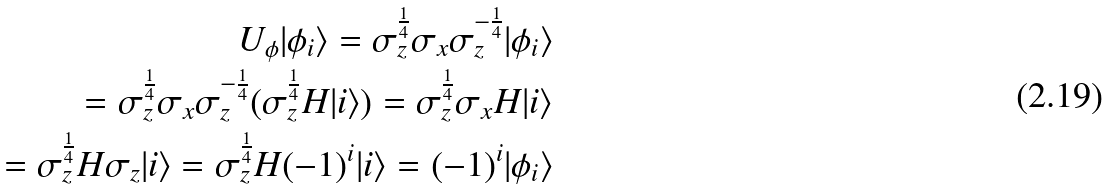<formula> <loc_0><loc_0><loc_500><loc_500>U _ { \phi } | \phi _ { i } \rangle = \sigma _ { z } ^ { \frac { 1 } { 4 } } \sigma _ { x } \sigma _ { z } ^ { - \frac { 1 } { 4 } } | \phi _ { i } \rangle \\ = \sigma _ { z } ^ { \frac { 1 } { 4 } } \sigma _ { x } \sigma _ { z } ^ { - \frac { 1 } { 4 } } ( \sigma _ { z } ^ { \frac { 1 } { 4 } } H | i \rangle ) = \sigma _ { z } ^ { \frac { 1 } { 4 } } \sigma _ { x } H | i \rangle \\ = \sigma _ { z } ^ { \frac { 1 } { 4 } } H \sigma _ { z } | i \rangle = \sigma _ { z } ^ { \frac { 1 } { 4 } } H ( - 1 ) ^ { i } | i \rangle = ( - 1 ) ^ { i } | \phi _ { i } \rangle</formula> 